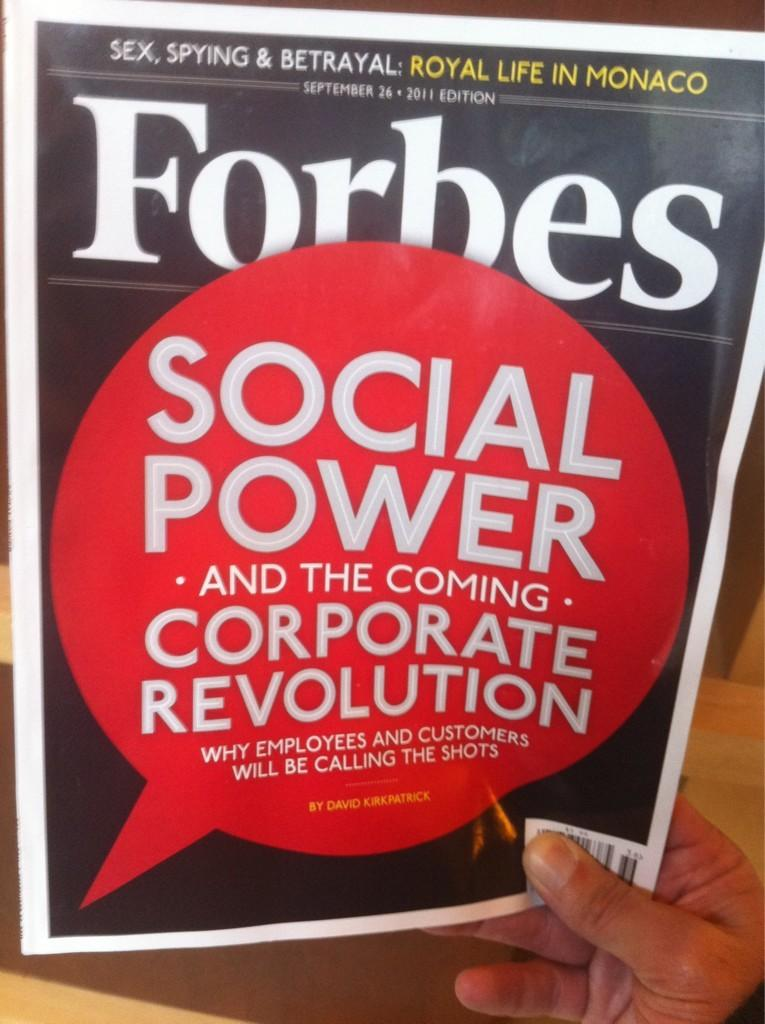<image>
Describe the image concisely. A person holding a Forbes Magazine with the title "Social Power" on front. 